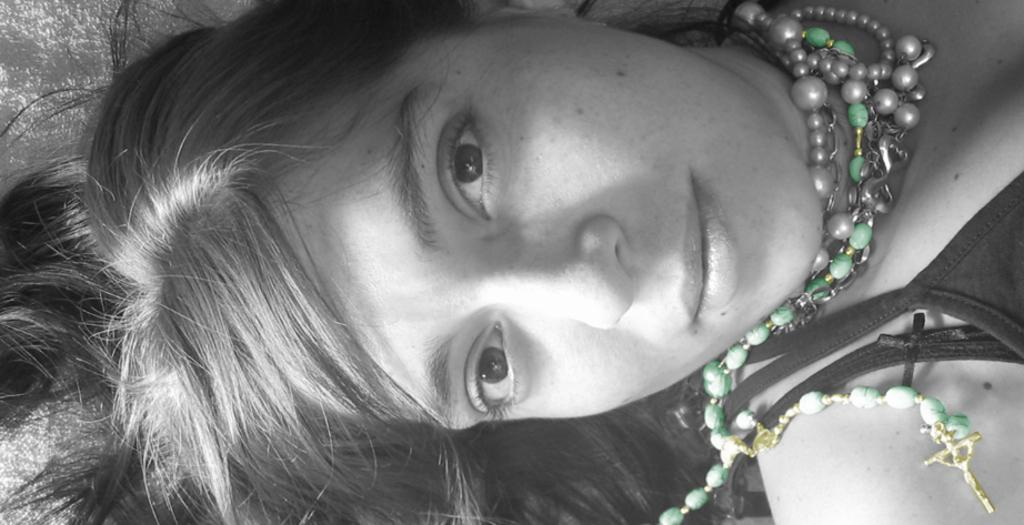What is the main subject of the image? There is a woman in the image. What is the woman wearing in the image? The woman is wearing a t-shirt and a beads necklace in the image. What is the woman's facial expression in the image? The woman is smiling in the image. What is the woman's position in the image? The woman is lying on the bed in the image. What is the color of the background in the image? The background of the image is white in color. Can you see a crown on the woman's head in the image? No, there is no crown present on the woman's head in the image. Is the woman holding a whip in the image? No, the woman is not holding a whip in the image. 